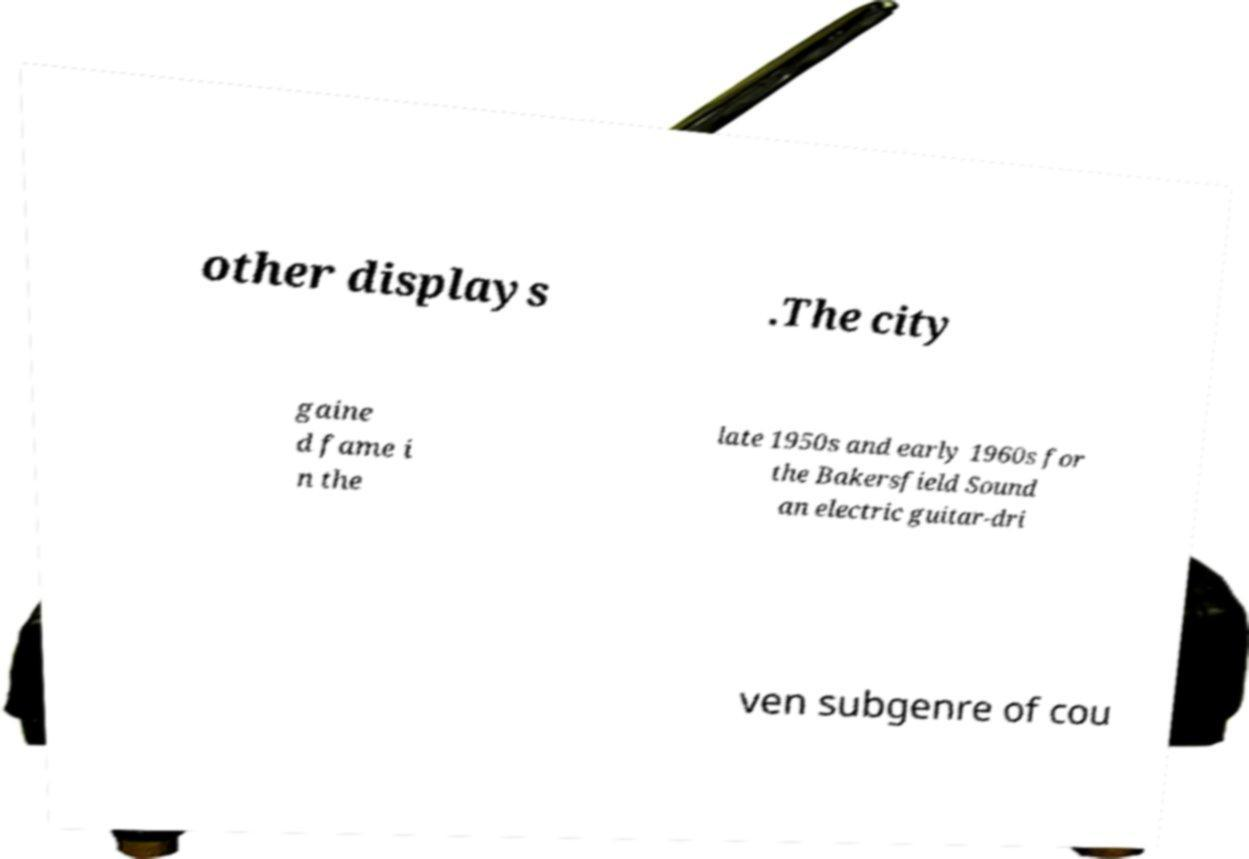Could you assist in decoding the text presented in this image and type it out clearly? other displays .The city gaine d fame i n the late 1950s and early 1960s for the Bakersfield Sound an electric guitar-dri ven subgenre of cou 